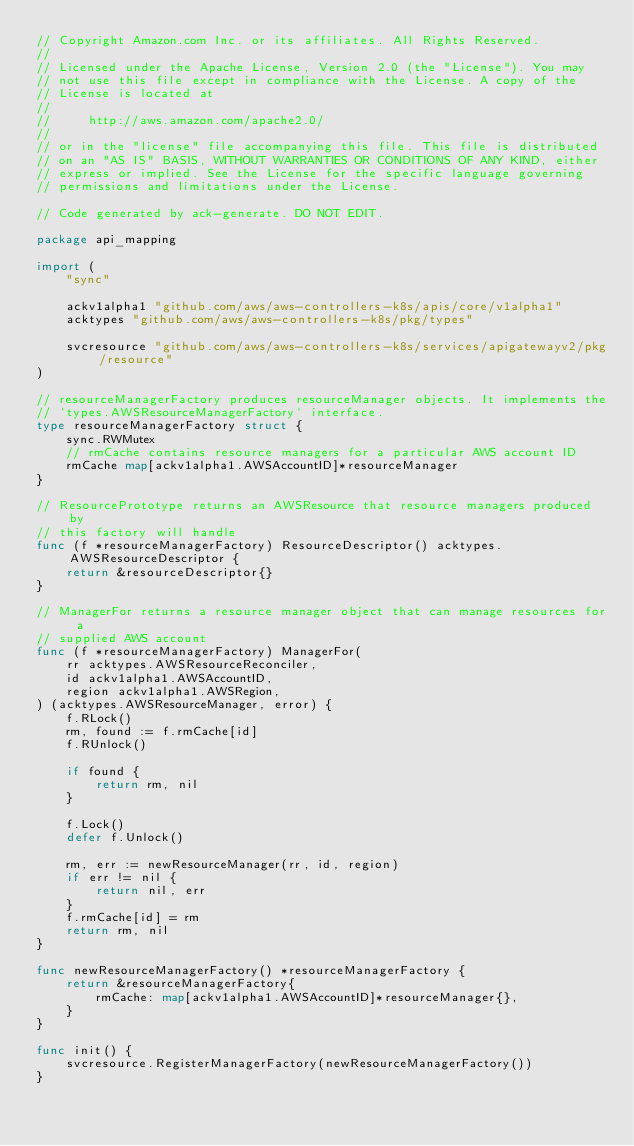<code> <loc_0><loc_0><loc_500><loc_500><_Go_>// Copyright Amazon.com Inc. or its affiliates. All Rights Reserved.
//
// Licensed under the Apache License, Version 2.0 (the "License"). You may
// not use this file except in compliance with the License. A copy of the
// License is located at
//
//     http://aws.amazon.com/apache2.0/
//
// or in the "license" file accompanying this file. This file is distributed
// on an "AS IS" BASIS, WITHOUT WARRANTIES OR CONDITIONS OF ANY KIND, either
// express or implied. See the License for the specific language governing
// permissions and limitations under the License.

// Code generated by ack-generate. DO NOT EDIT.

package api_mapping

import (
	"sync"

	ackv1alpha1 "github.com/aws/aws-controllers-k8s/apis/core/v1alpha1"
	acktypes "github.com/aws/aws-controllers-k8s/pkg/types"

	svcresource "github.com/aws/aws-controllers-k8s/services/apigatewayv2/pkg/resource"
)

// resourceManagerFactory produces resourceManager objects. It implements the
// `types.AWSResourceManagerFactory` interface.
type resourceManagerFactory struct {
	sync.RWMutex
	// rmCache contains resource managers for a particular AWS account ID
	rmCache map[ackv1alpha1.AWSAccountID]*resourceManager
}

// ResourcePrototype returns an AWSResource that resource managers produced by
// this factory will handle
func (f *resourceManagerFactory) ResourceDescriptor() acktypes.AWSResourceDescriptor {
	return &resourceDescriptor{}
}

// ManagerFor returns a resource manager object that can manage resources for a
// supplied AWS account
func (f *resourceManagerFactory) ManagerFor(
	rr acktypes.AWSResourceReconciler,
	id ackv1alpha1.AWSAccountID,
	region ackv1alpha1.AWSRegion,
) (acktypes.AWSResourceManager, error) {
	f.RLock()
	rm, found := f.rmCache[id]
	f.RUnlock()

	if found {
		return rm, nil
	}

	f.Lock()
	defer f.Unlock()

	rm, err := newResourceManager(rr, id, region)
	if err != nil {
		return nil, err
	}
	f.rmCache[id] = rm
	return rm, nil
}

func newResourceManagerFactory() *resourceManagerFactory {
	return &resourceManagerFactory{
		rmCache: map[ackv1alpha1.AWSAccountID]*resourceManager{},
	}
}

func init() {
	svcresource.RegisterManagerFactory(newResourceManagerFactory())
}
</code> 